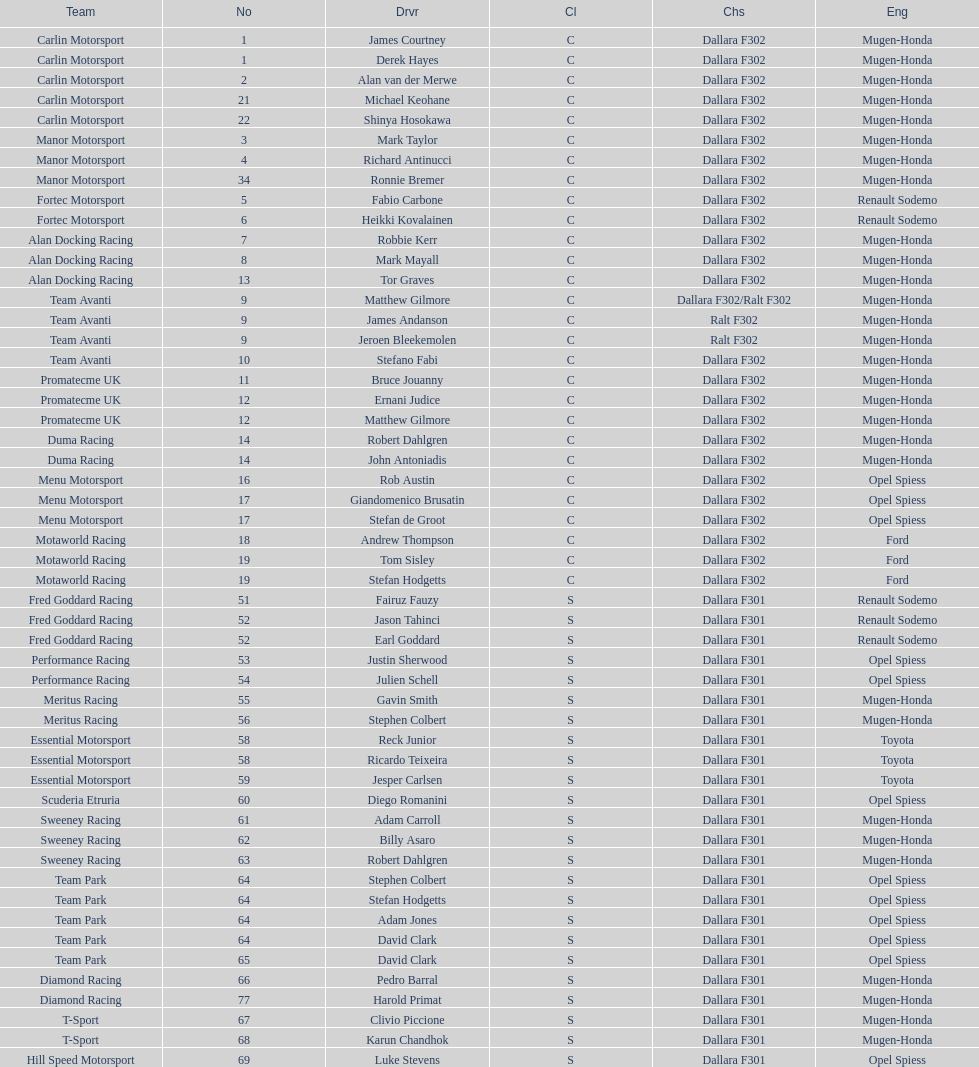What is the total number of class c (championship) teams? 21. 